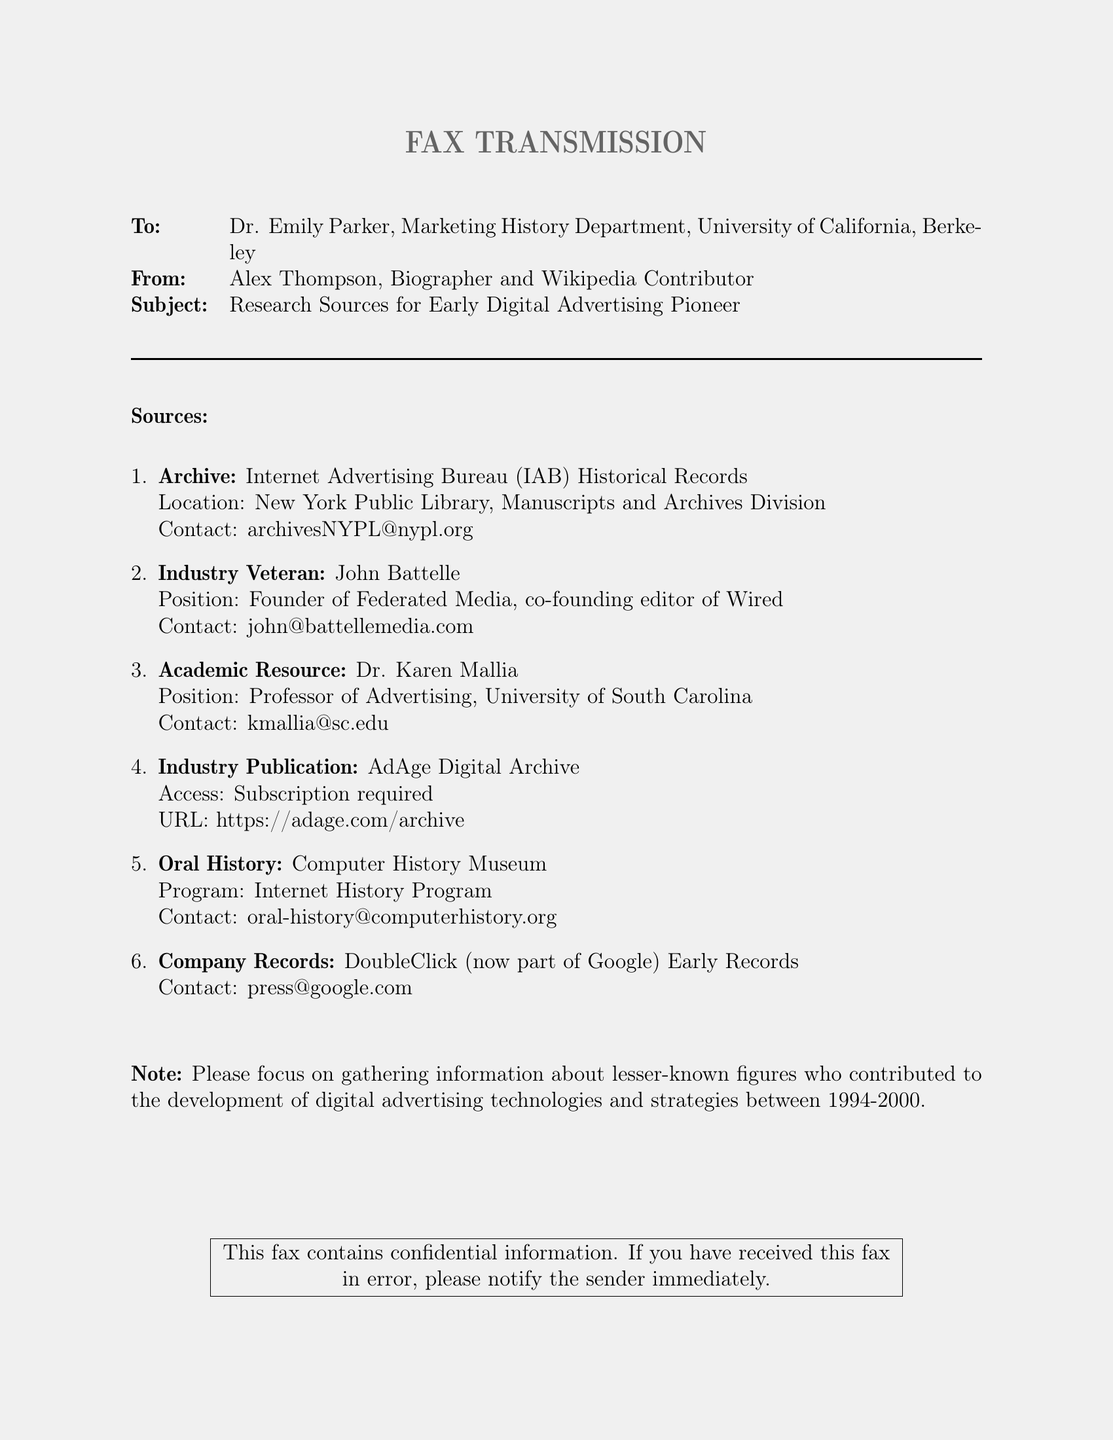What is the subject of the fax? The subject of the fax is the topic being addressed, which pertains to research sources for a specific individual related to marketing.
Answer: Research Sources for Early Digital Advertising Pioneer Who is the sender of the fax? The sender's name and role are provided at the beginning of the document, which identifies who is sending the information.
Answer: Alex Thompson What is the email address for the Internet Advertising Bureau archives? The document lists a specific contact email for the IAB Historical Records, necessary for reaching out for archives information.
Answer: archivesNYPL@nypl.org Which university does Dr. Karen Mallia work for? The document specifies Dr. Mallia’s position and her associated institution, aiding in identifying her academic background.
Answer: University of South Carolina How many industry sources are listed in the fax? By counting the number of sources enumerated in the document, one can provide the total number of contacts available for research.
Answer: Six What is the contact email for John Battelle? This question seeks specific information about the contact provided for a notable industry veteran mentioned in the fax.
Answer: john@battellemedia.com What does the note specify for information gathering? The note gives specific instructions regarding the focus of the research, highlighting the type of figures to be investigated.
Answer: Lesser-known figures Which archive requires a subscription for access? This inquiry targets a specific resource mentioned in the document that requires payment or membership for entry.
Answer: AdAge Digital Archive What program does the Computer History Museum offer? The document includes a specific program related to oral histories that can provide valuable insights into the marketing field.
Answer: Internet History Program 